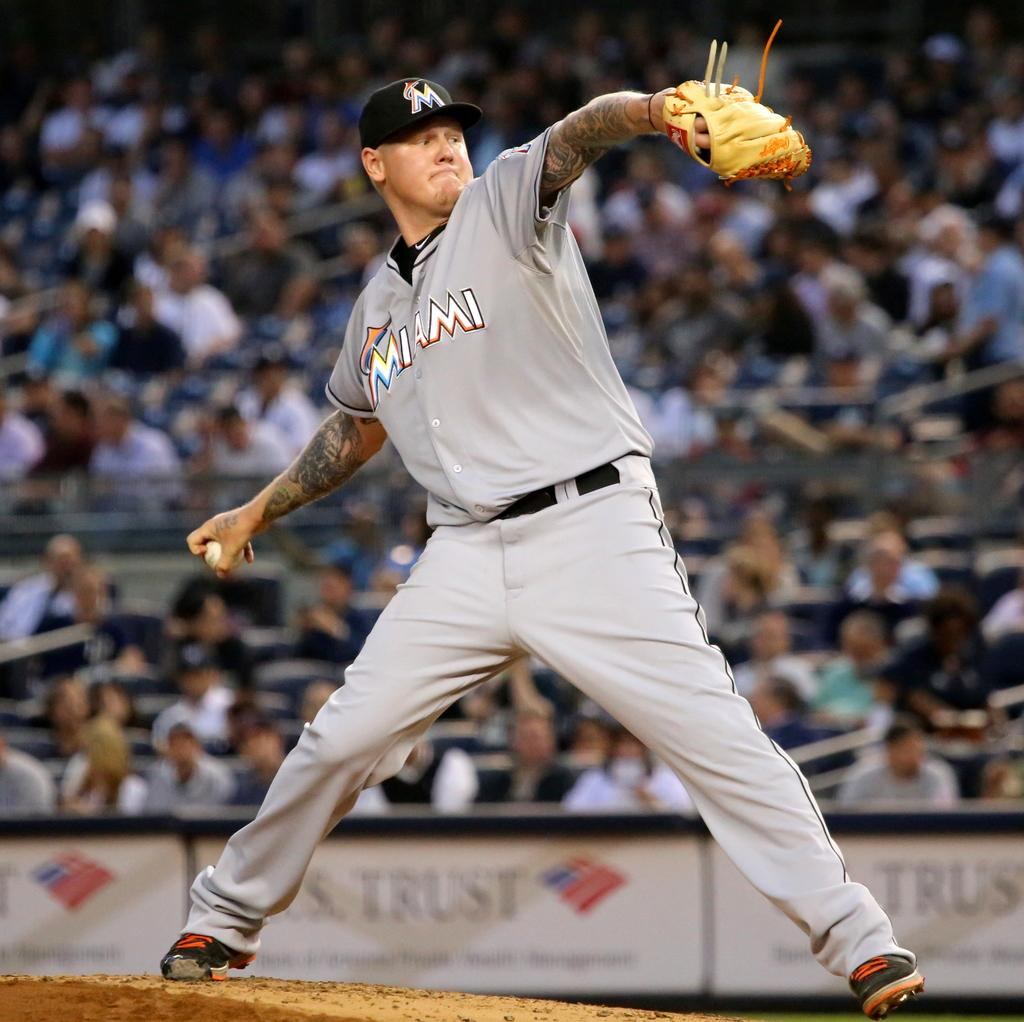<image>
Summarize the visual content of the image. A baseball pitcher stands on the mound making a pitch he plays for Miami 